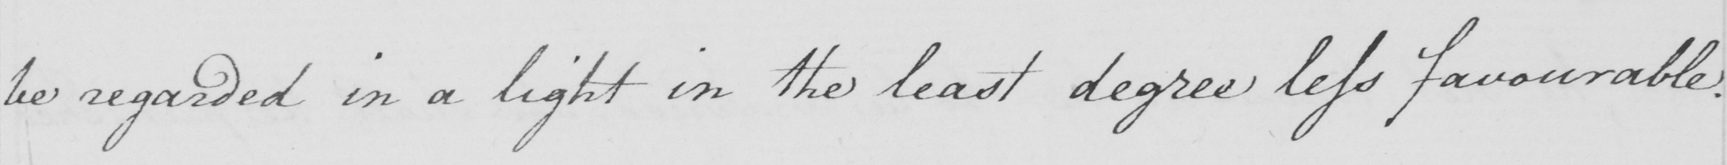What text is written in this handwritten line? be regarded in a light in the least degree less favourable . 